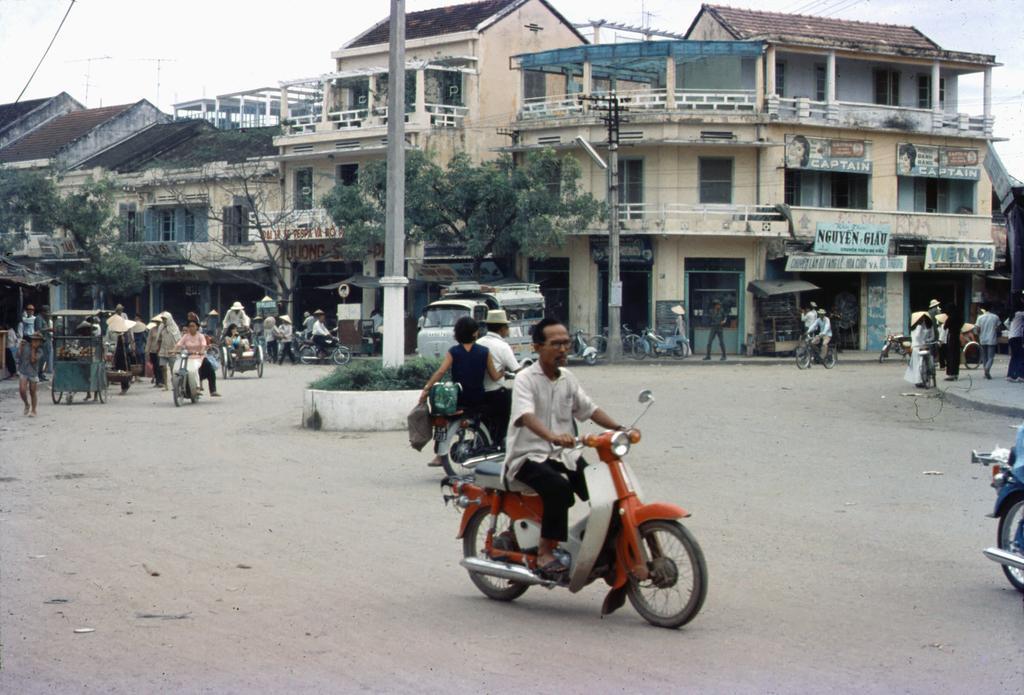Can you describe this image briefly? This image is clicked outside. There are buildings on the middle and there are so many people who are on vehicles. There are trees in the middle. There is sky in the top. There is a pillar in the middle. 